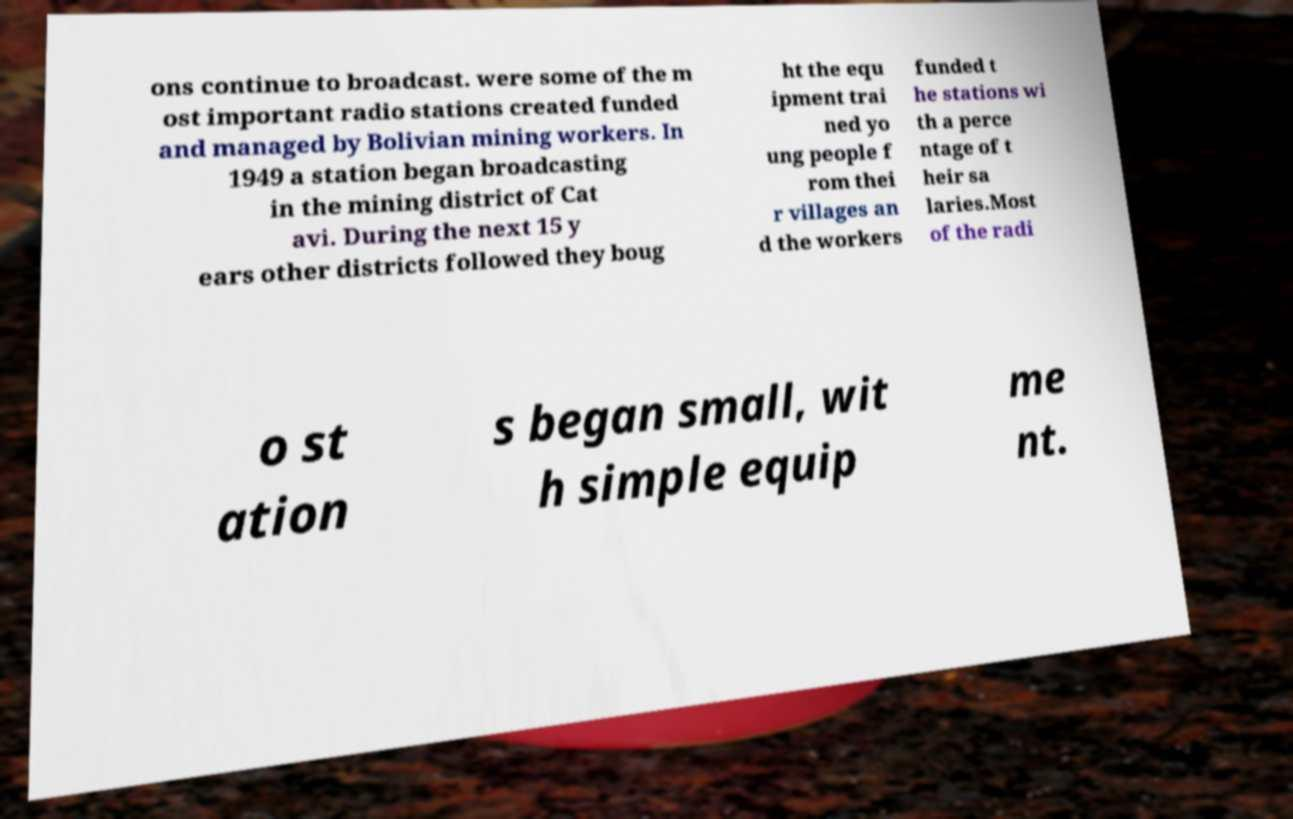For documentation purposes, I need the text within this image transcribed. Could you provide that? ons continue to broadcast. were some of the m ost important radio stations created funded and managed by Bolivian mining workers. In 1949 a station began broadcasting in the mining district of Cat avi. During the next 15 y ears other districts followed they boug ht the equ ipment trai ned yo ung people f rom thei r villages an d the workers funded t he stations wi th a perce ntage of t heir sa laries.Most of the radi o st ation s began small, wit h simple equip me nt. 